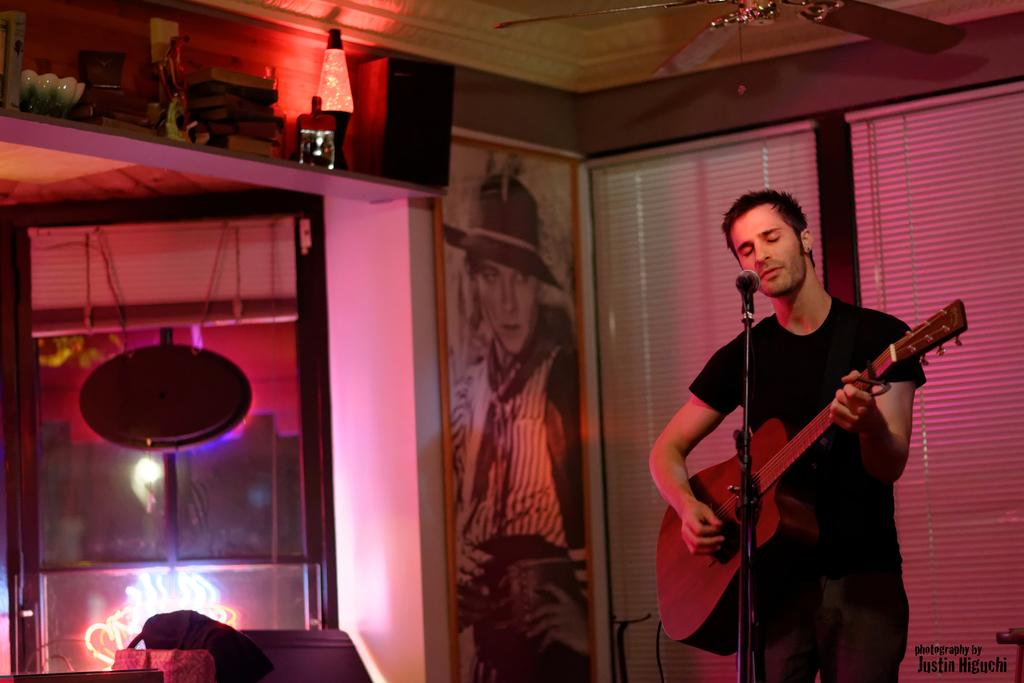What is the man in the image doing? The man is standing, playing a guitar, singing a song, and using a microphone. What object is the man using to amplify his voice? The man is using a microphone. What can be seen in the background of the image? There is a window visible in the image. What type of vegetable is being used as a prop in the image? There is no vegetable present in the image; the man is using a microphone for amplification. 